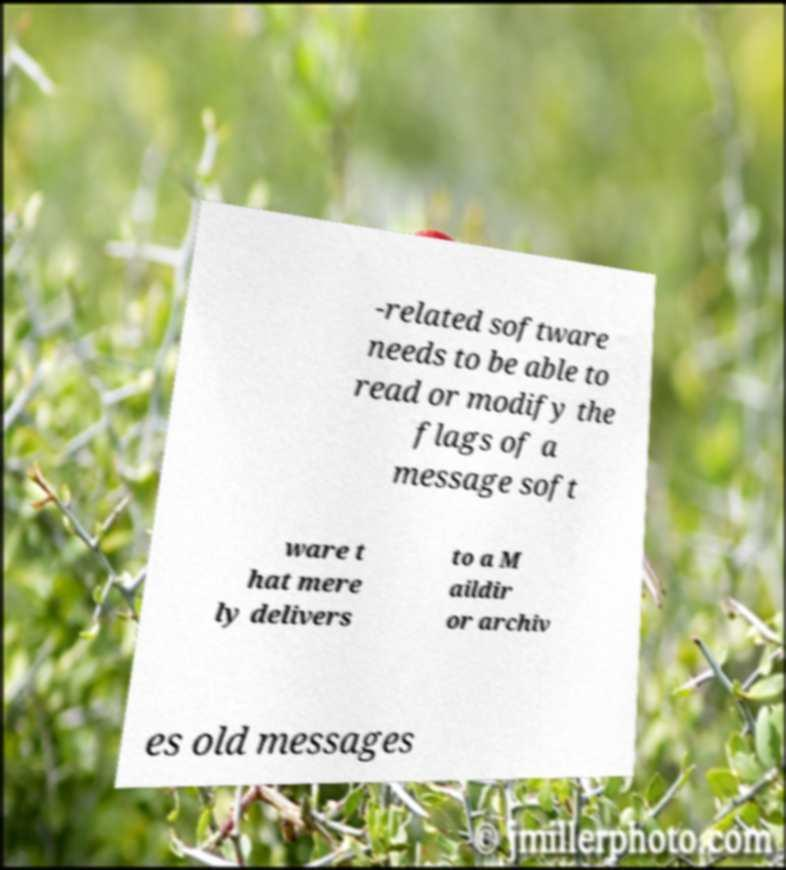Please identify and transcribe the text found in this image. -related software needs to be able to read or modify the flags of a message soft ware t hat mere ly delivers to a M aildir or archiv es old messages 